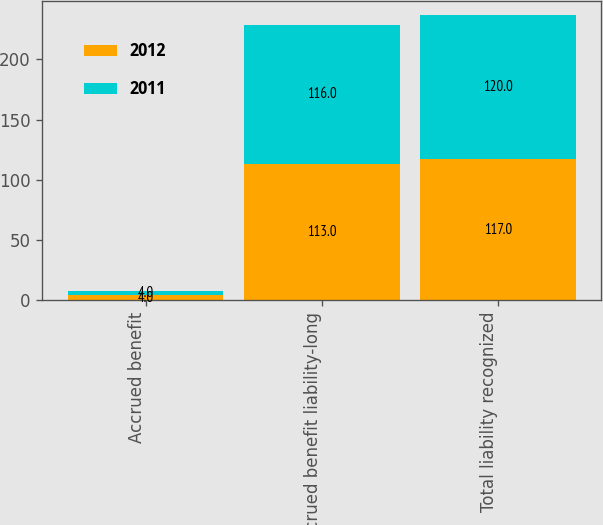<chart> <loc_0><loc_0><loc_500><loc_500><stacked_bar_chart><ecel><fcel>Accrued benefit<fcel>Accrued benefit liability-long<fcel>Total liability recognized<nl><fcel>2012<fcel>4<fcel>113<fcel>117<nl><fcel>2011<fcel>4<fcel>116<fcel>120<nl></chart> 